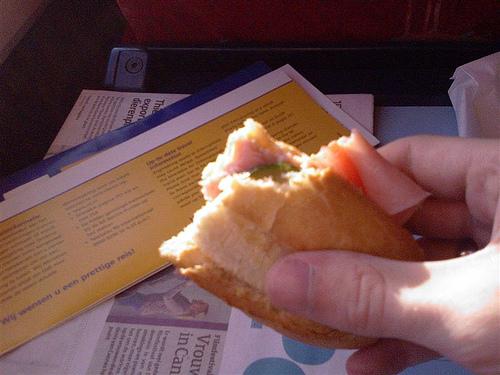What hand is being used?
Concise answer only. Right. Is there bologna on this sandwich?
Concise answer only. Yes. Does the person with the sandwich like pickles?
Write a very short answer. Yes. 